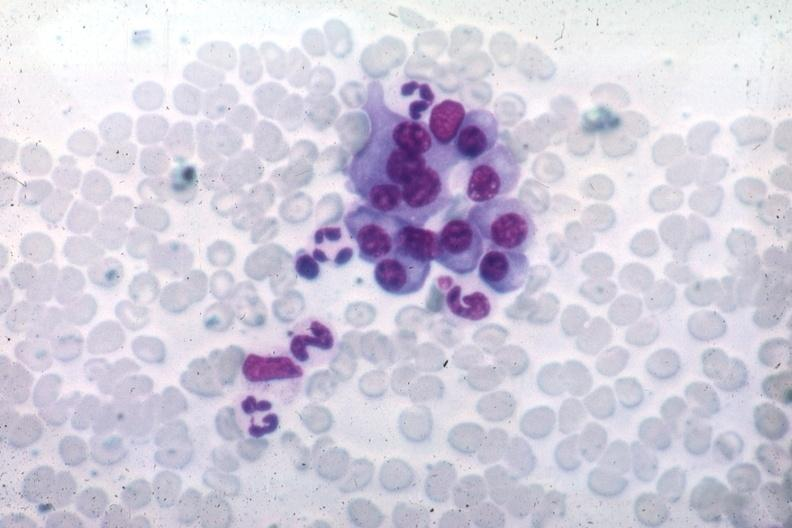s opened dysmorphic body with all organs except kidneys differentiated plasma cells source unknown?
Answer the question using a single word or phrase. No 